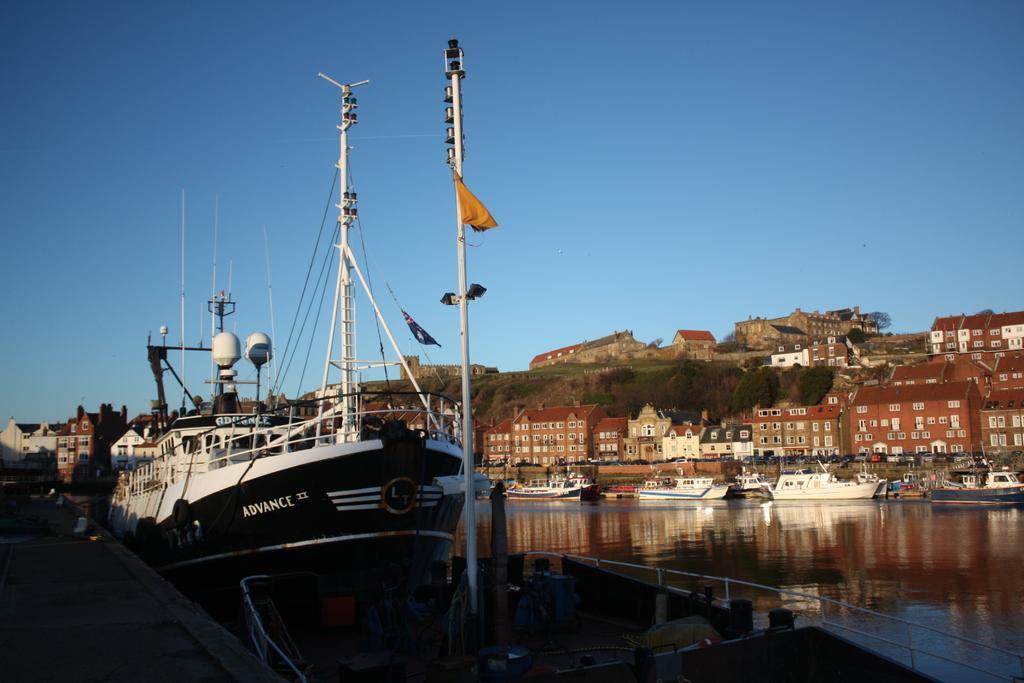Please provide a concise description of this image. In this image there are ships in the water. At the right side of the image there are buildings, trees. At the background there is sky. 